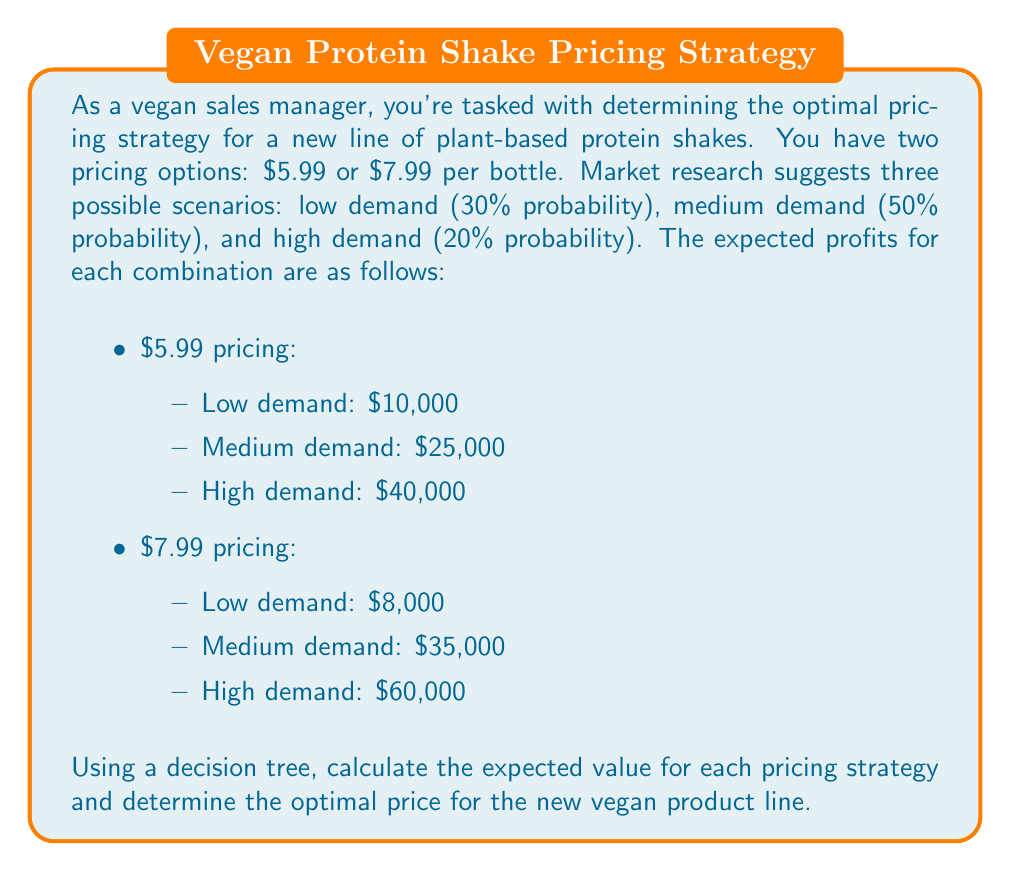Can you solve this math problem? To solve this problem, we'll construct a decision tree and calculate the expected value for each pricing strategy. Here's the step-by-step process:

1. Construct the decision tree:
   [asy]
   import geometry;

   // Decision node
   dot((0,0));
   draw((0,0)--(2,1));
   draw((0,0)--(2,-1));
   label("$5.99", (1,0.7), E);
   label("$7.99", (1,-0.7), E);

   // Chance nodes
   dot((2,1));
   dot((2,-1));

   // Outcomes for $5.99
   draw((2,1)--(4,2));
   draw((2,1)--(4,1));
   draw((2,1)--(4,0));
   label("Low (30%): $10,000", (3,2), E);
   label("Medium (50%): $25,000", (3,1), E);
   label("High (20%): $40,000", (3,0), E);

   // Outcomes for $7.99
   draw((2,-1)--(4,-2));
   draw((2,-1)--(4,-1));
   draw((2,-1)--(4,0));
   label("Low (30%): $8,000", (3,-2), E);
   label("Medium (50%): $35,000", (3,-1), E);
   label("High (20%): $60,000", (3,0), E);
   [/asy]

2. Calculate the expected value for the $5.99 pricing strategy:
   $$EV_{5.99} = (0.30 \times 10000) + (0.50 \times 25000) + (0.20 \times 40000)$$
   $$EV_{5.99} = 3000 + 12500 + 8000 = 23500$$

3. Calculate the expected value for the $7.99 pricing strategy:
   $$EV_{7.99} = (0.30 \times 8000) + (0.50 \times 35000) + (0.20 \times 60000)$$
   $$EV_{7.99} = 2400 + 17500 + 12000 = 31900$$

4. Compare the expected values:
   The expected value for the $7.99 pricing strategy ($31,900) is higher than the expected value for the $5.99 pricing strategy ($23,500).

5. Make a decision:
   Based on the expected values, the optimal pricing strategy is to price the new vegan protein shake at $7.99 per bottle.
Answer: The optimal pricing strategy for the new vegan product line is $7.99 per bottle, with an expected value of $31,900. 